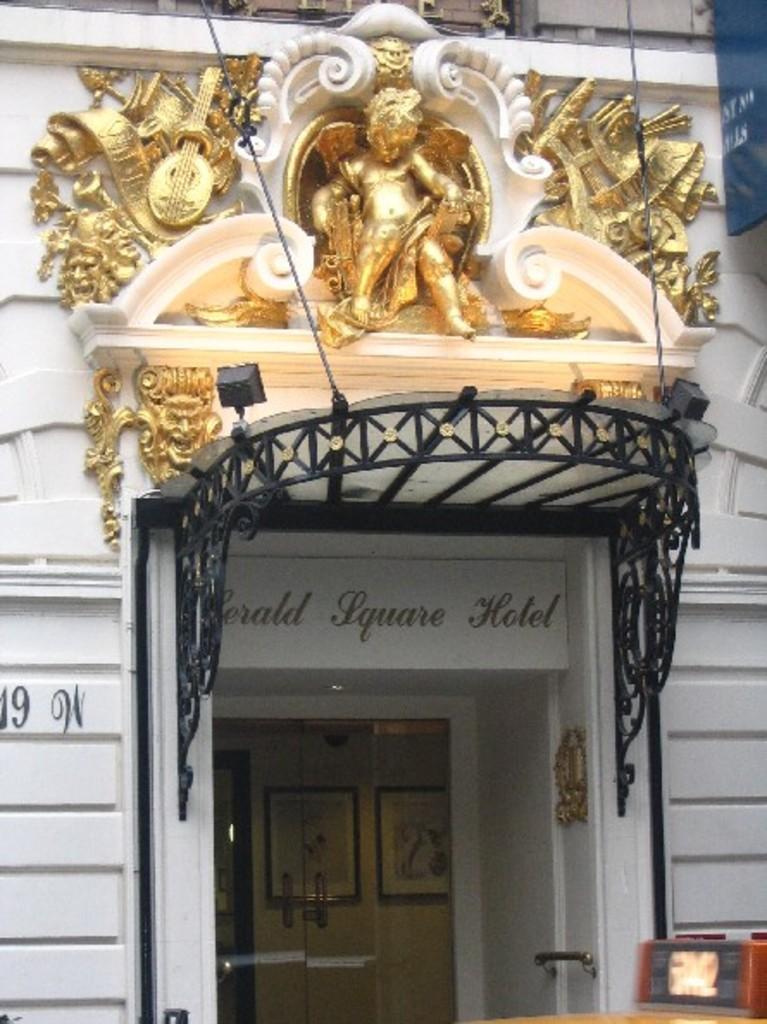Describe this image in one or two sentences. In this image we can see sculptures and designs on the wall. There are texts on the wall and we can see doors. Through the glass we can see frames on the wall. On the right side we can see objects. 